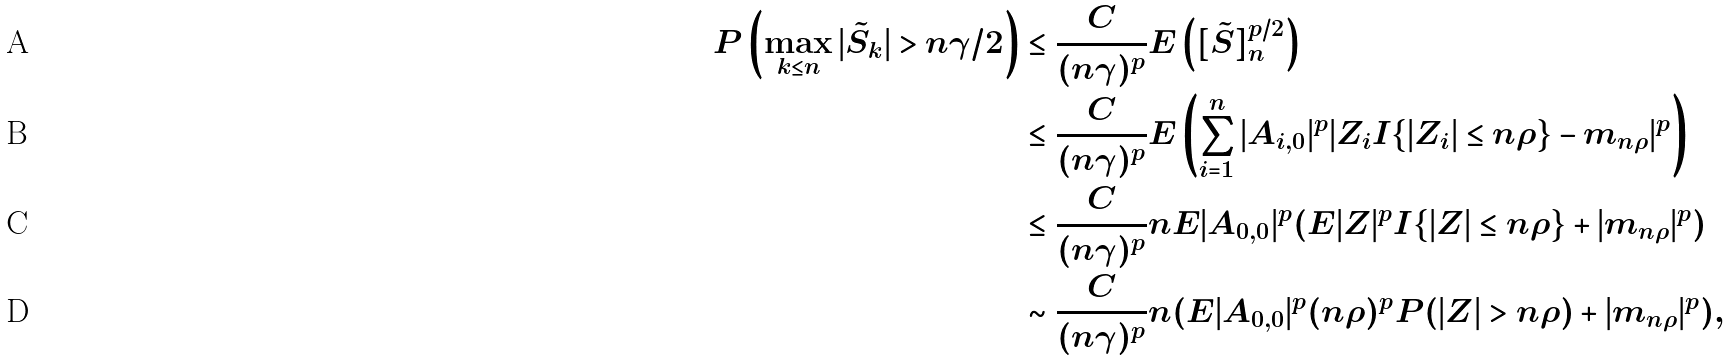<formula> <loc_0><loc_0><loc_500><loc_500>P \left ( \max _ { k \leq n } | \tilde { S } _ { k } | > n \gamma / 2 \right ) & \leq \frac { C } { ( n \gamma ) ^ { p } } E \left ( [ \tilde { S } ] _ { n } ^ { p / 2 } \right ) \\ & \leq \frac { C } { ( n \gamma ) ^ { p } } E \left ( \sum _ { i = 1 } ^ { n } | A _ { i , 0 } | ^ { p } | Z _ { i } I \{ | Z _ { i } | \leq n \rho \} - m _ { n \rho } | ^ { p } \right ) \\ & \leq \frac { C } { ( n \gamma ) ^ { p } } n E | A _ { 0 , 0 } | ^ { p } ( E | Z | ^ { p } I \{ | Z | \leq n \rho \} + | m _ { n \rho } | ^ { p } ) \\ & \sim \frac { C } { ( n \gamma ) ^ { p } } n ( E | A _ { 0 , 0 } | ^ { p } ( n \rho ) ^ { p } P ( | Z | > n \rho ) + | m _ { n \rho } | ^ { p } ) ,</formula> 